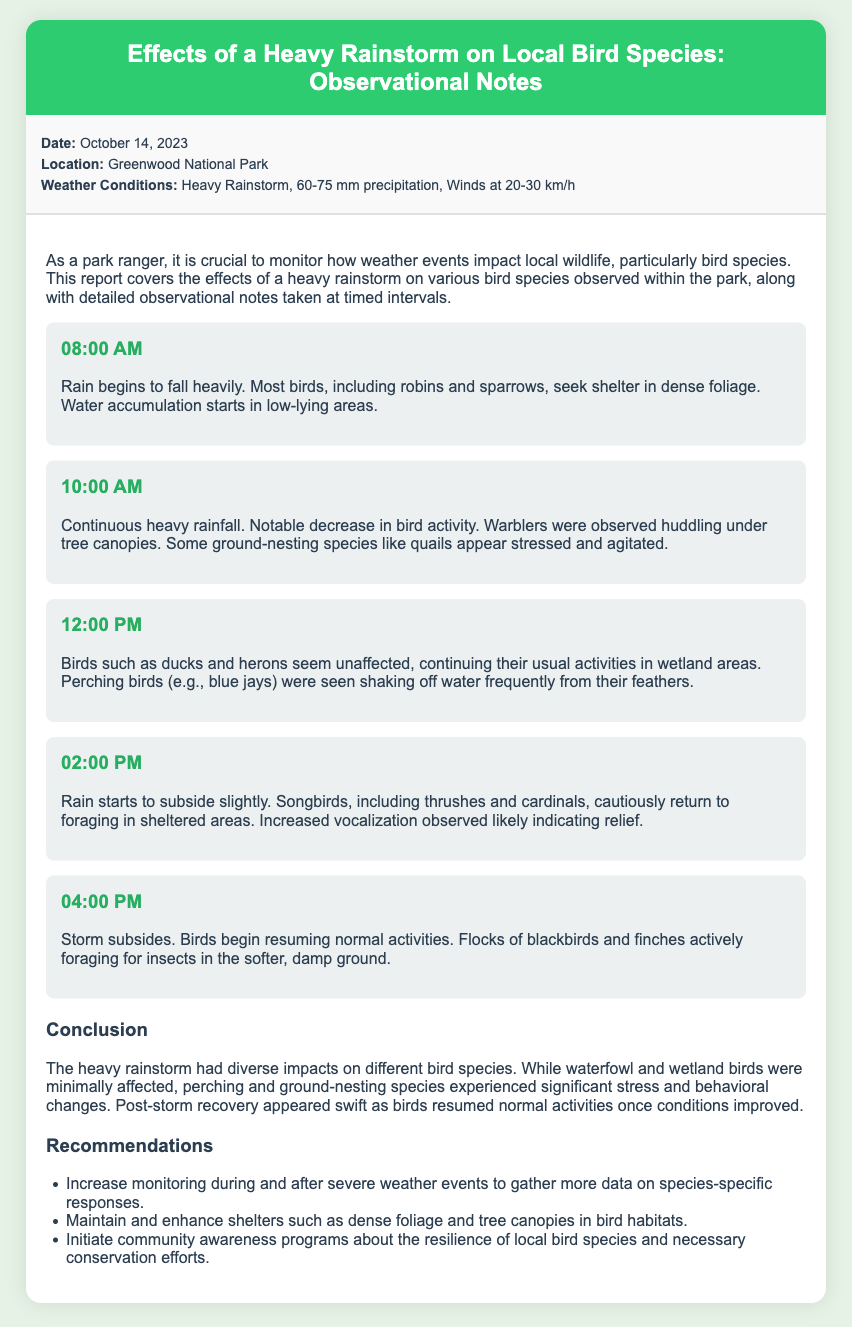what is the date of the observations? The date is mentioned in the info section of the document.
Answer: October 14, 2023 what weather conditions were reported? The weather conditions are specified in the info section of the document.
Answer: Heavy Rainstorm, 60-75 mm precipitation, Winds at 20-30 km/h which bird species were noted as experiencing stress? The document lists specific bird species that showed stress during the storm.
Answer: quails at what time did the rain start to subside? The time the rain began to lessen is specified in the interval observations.
Answer: 02:00 PM which birds were seen shaking off water frequently? The document mentions specific birds reacting to the rain.
Answer: blue jays what is the main conclusion of the observations? The conclusion summarizes the overall impact of the rainstorm on the birds.
Answer: diverse impacts on different bird species what recommendation is made regarding monitoring? The recommendations section provides specific suggestions about monitoring.
Answer: Increase monitoring during and after severe weather events how did ground-nesting species react to the storm? The document highlights the behavior of ground-nesting birds under stress.
Answer: experienced significant stress and behavioral changes 